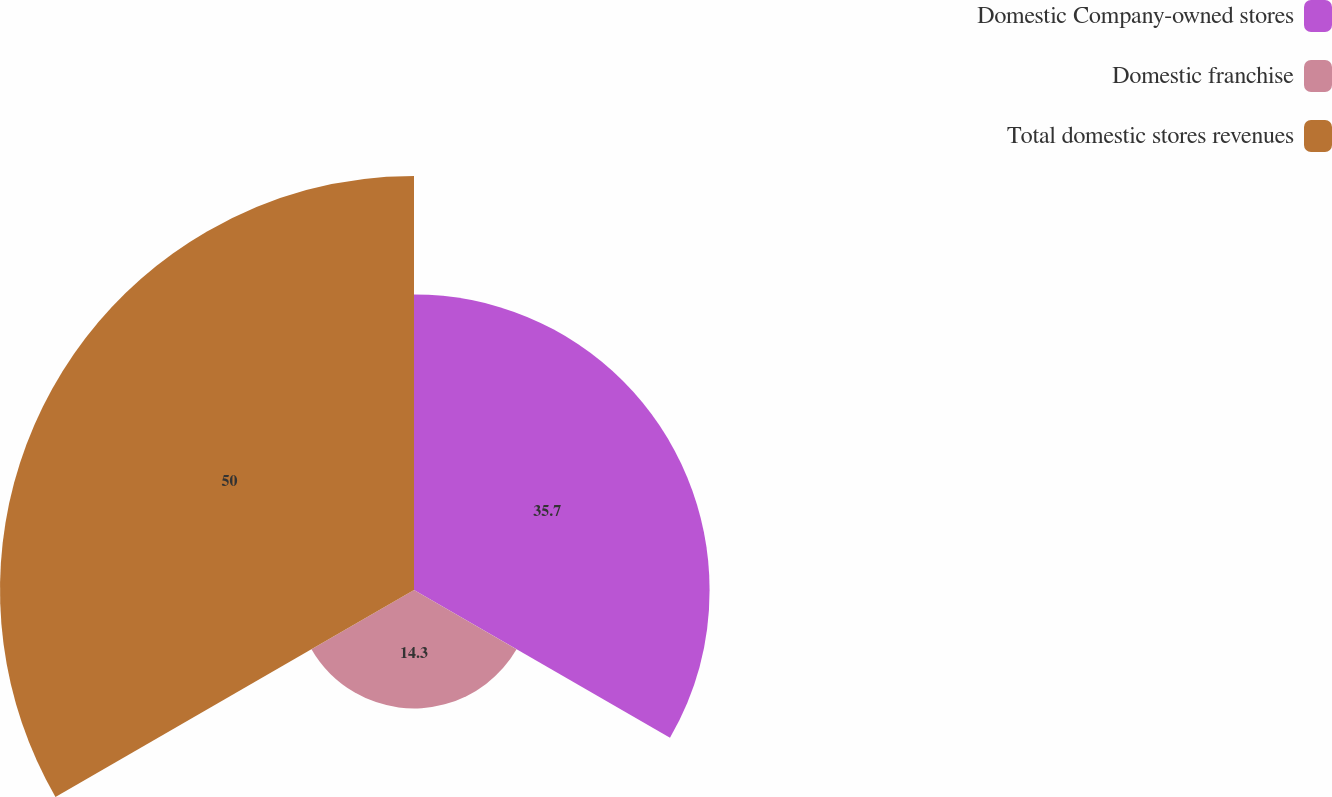Convert chart to OTSL. <chart><loc_0><loc_0><loc_500><loc_500><pie_chart><fcel>Domestic Company-owned stores<fcel>Domestic franchise<fcel>Total domestic stores revenues<nl><fcel>35.7%<fcel>14.3%<fcel>50.0%<nl></chart> 